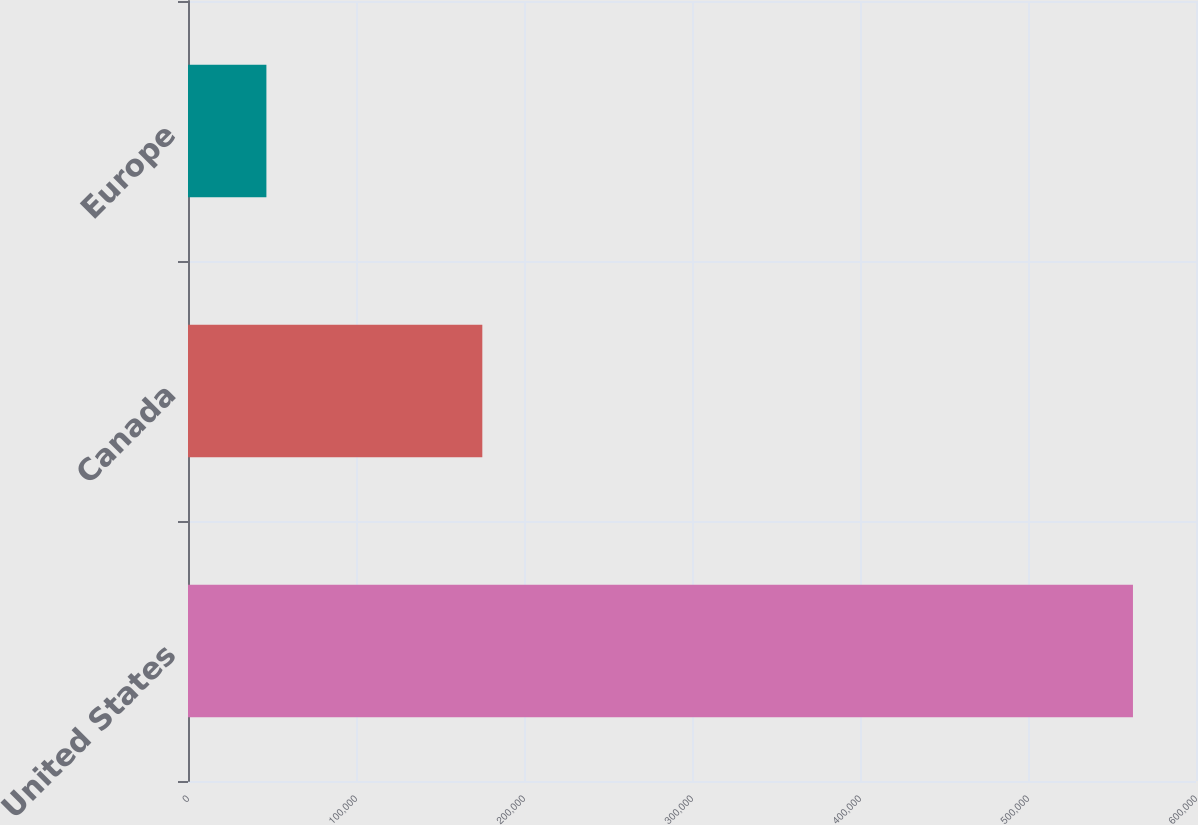<chart> <loc_0><loc_0><loc_500><loc_500><bar_chart><fcel>United States<fcel>Canada<fcel>Europe<nl><fcel>562475<fcel>175190<fcel>46666<nl></chart> 